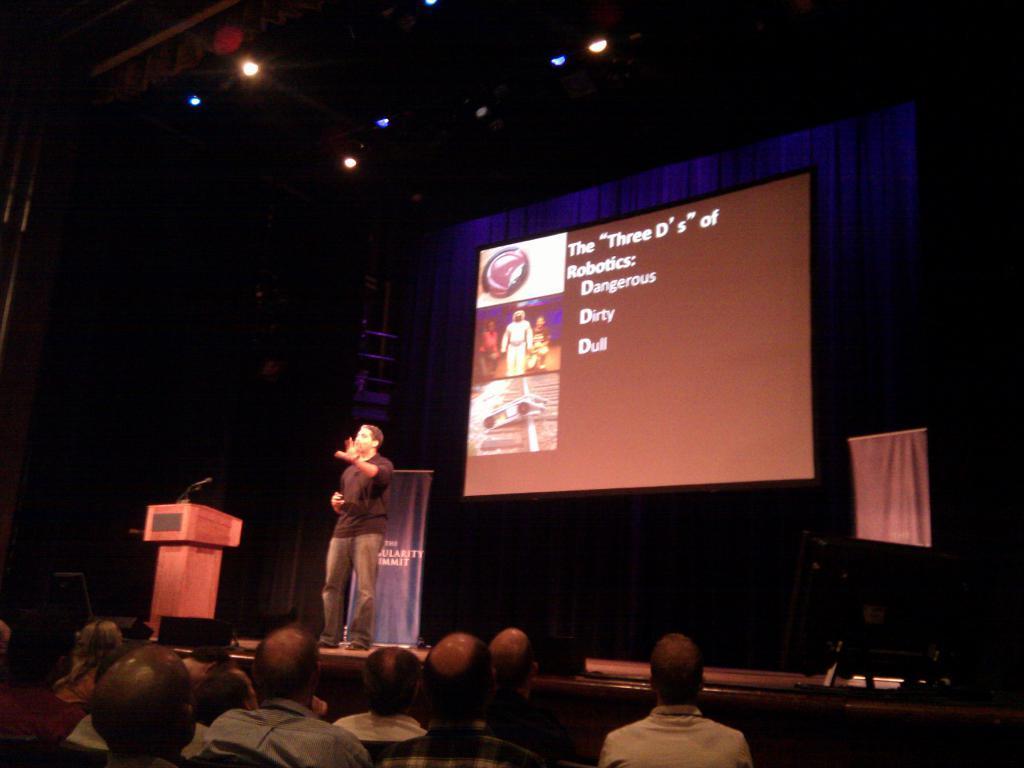How would you summarize this image in a sentence or two? In this image I can see group of people sitting and I can also see the person standing and the person is wearing black color shirt and I can see the podium and the microphone. In the background I can see the screen and few curtains. 